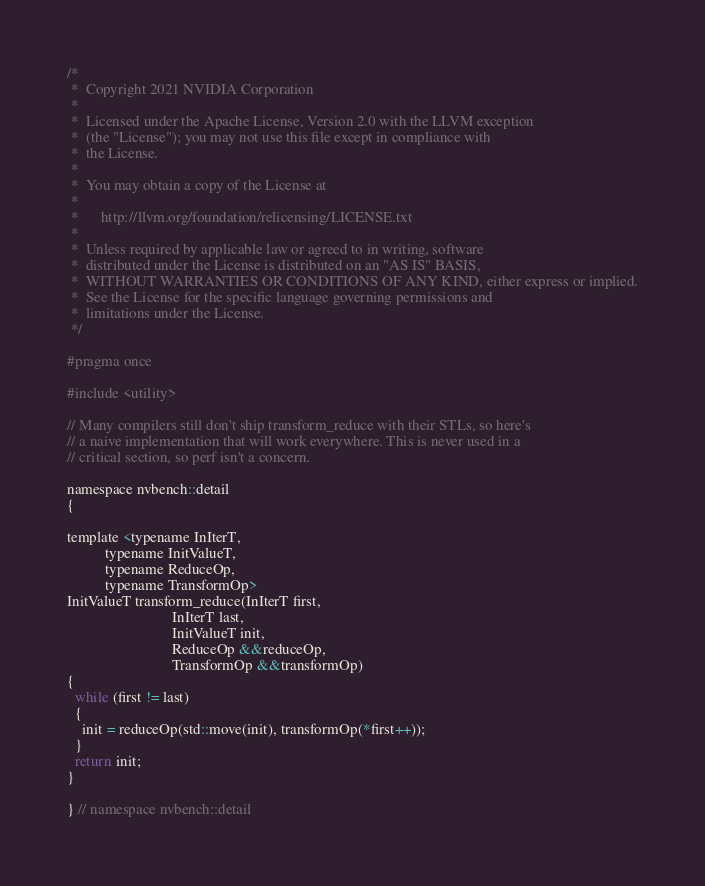<code> <loc_0><loc_0><loc_500><loc_500><_Cuda_>/*
 *  Copyright 2021 NVIDIA Corporation
 *
 *  Licensed under the Apache License, Version 2.0 with the LLVM exception
 *  (the "License"); you may not use this file except in compliance with
 *  the License.
 *
 *  You may obtain a copy of the License at
 *
 *      http://llvm.org/foundation/relicensing/LICENSE.txt
 *
 *  Unless required by applicable law or agreed to in writing, software
 *  distributed under the License is distributed on an "AS IS" BASIS,
 *  WITHOUT WARRANTIES OR CONDITIONS OF ANY KIND, either express or implied.
 *  See the License for the specific language governing permissions and
 *  limitations under the License.
 */

#pragma once

#include <utility>

// Many compilers still don't ship transform_reduce with their STLs, so here's
// a naive implementation that will work everywhere. This is never used in a
// critical section, so perf isn't a concern.

namespace nvbench::detail
{

template <typename InIterT,
          typename InitValueT,
          typename ReduceOp,
          typename TransformOp>
InitValueT transform_reduce(InIterT first,
                            InIterT last,
                            InitValueT init,
                            ReduceOp &&reduceOp,
                            TransformOp &&transformOp)
{
  while (first != last)
  {
    init = reduceOp(std::move(init), transformOp(*first++));
  }
  return init;
}

} // namespace nvbench::detail
</code> 